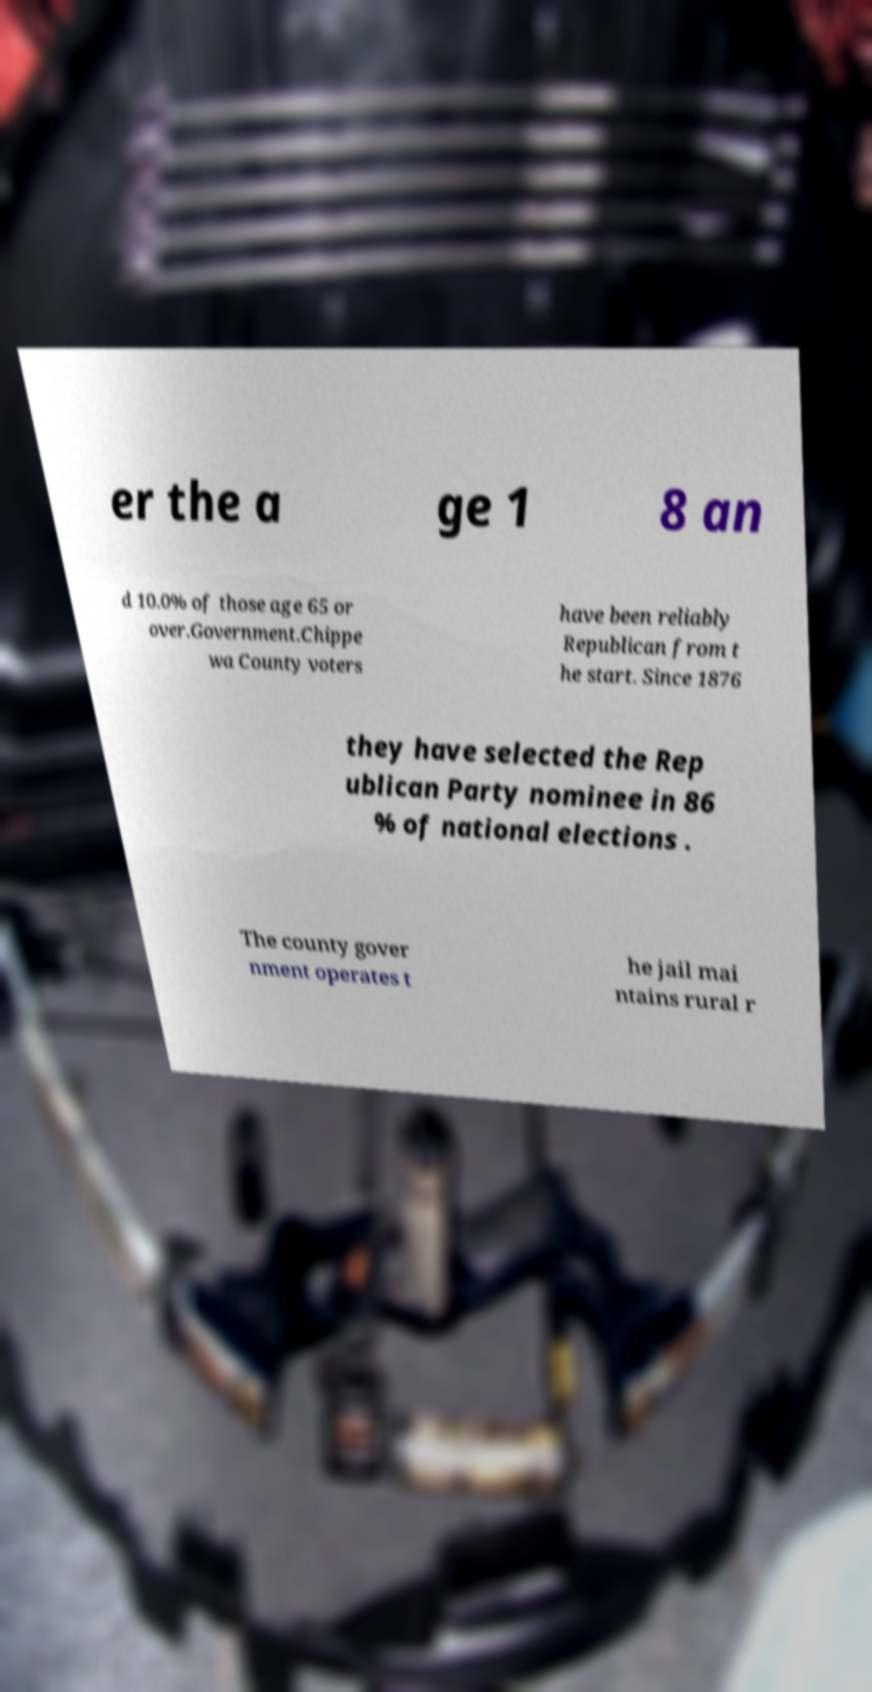Please identify and transcribe the text found in this image. er the a ge 1 8 an d 10.0% of those age 65 or over.Government.Chippe wa County voters have been reliably Republican from t he start. Since 1876 they have selected the Rep ublican Party nominee in 86 % of national elections . The county gover nment operates t he jail mai ntains rural r 